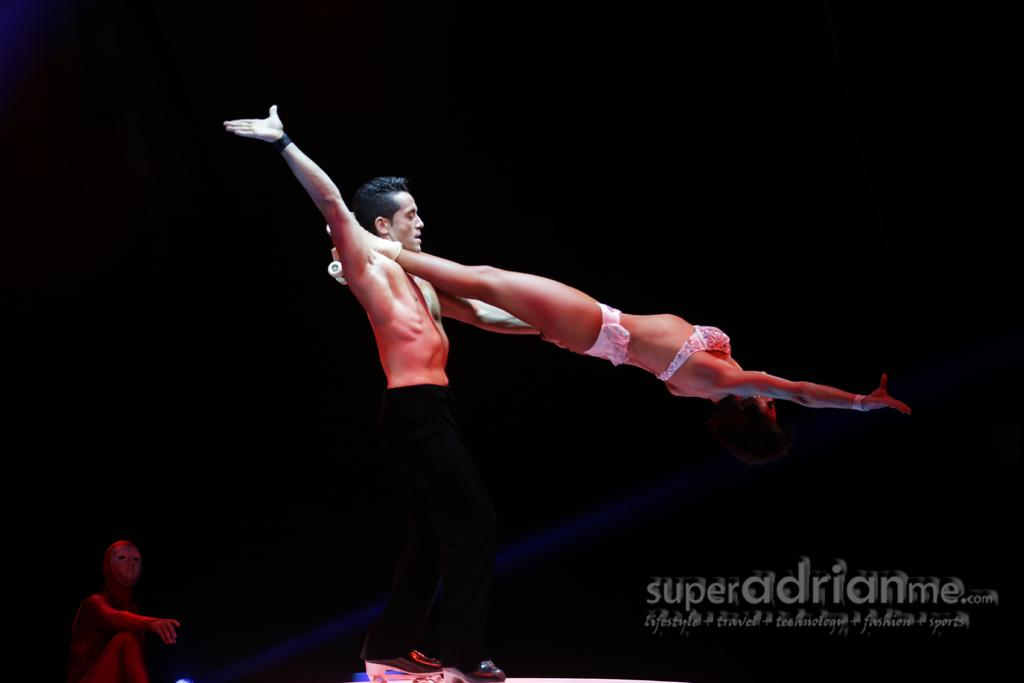What is the main subject of the image? There is a man in the image. What is the man doing in the image? The man is holding a woman. Are there any other people in the image? Yes, there is another woman sitting in the image. What type of stitch is the man using to hold the woman in the image? The man is not using a stitch to hold the woman; he is holding her with his arms. Is there a bath visible in the image? No, there is no bath present in the image. 